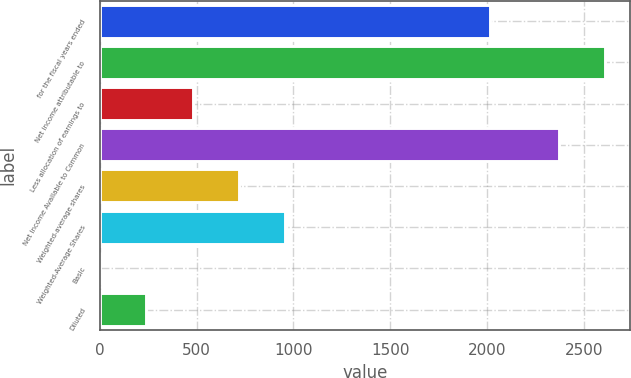Convert chart. <chart><loc_0><loc_0><loc_500><loc_500><bar_chart><fcel>for the fiscal years ended<fcel>Net income attributable to<fcel>Less allocation of earnings to<fcel>Net Income Available to Common<fcel>Weighted-average shares<fcel>Weighted-Average Shares<fcel>Basic<fcel>Diluted<nl><fcel>2014<fcel>2608.05<fcel>479.89<fcel>2370<fcel>717.94<fcel>955.99<fcel>3.79<fcel>241.84<nl></chart> 